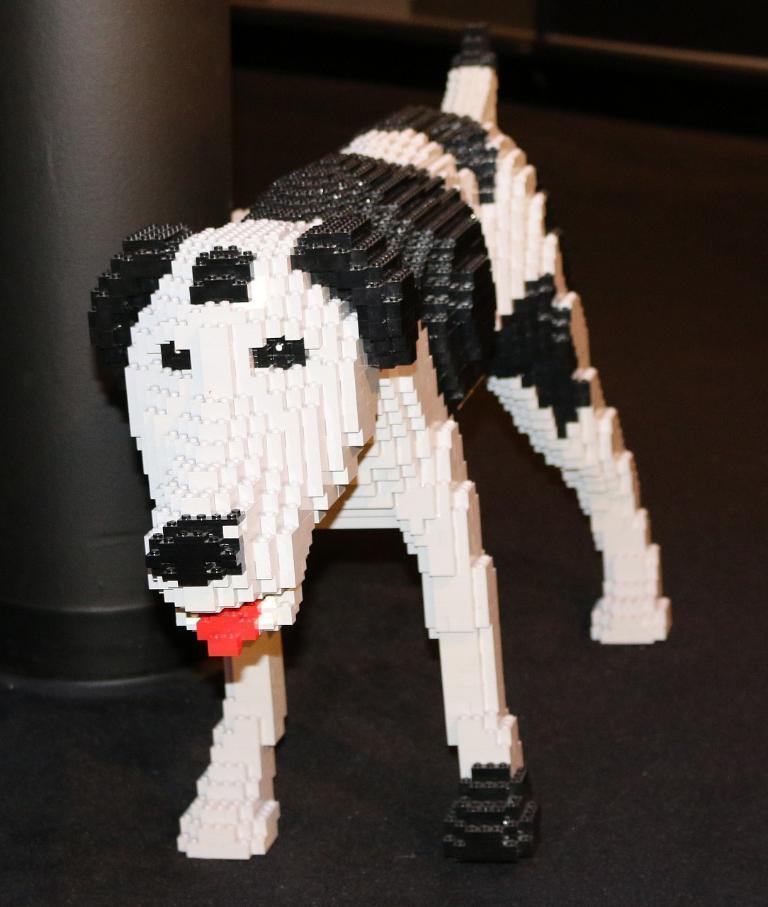Could you give a brief overview of what you see in this image? This is a black and white color dog, this is pillar. 